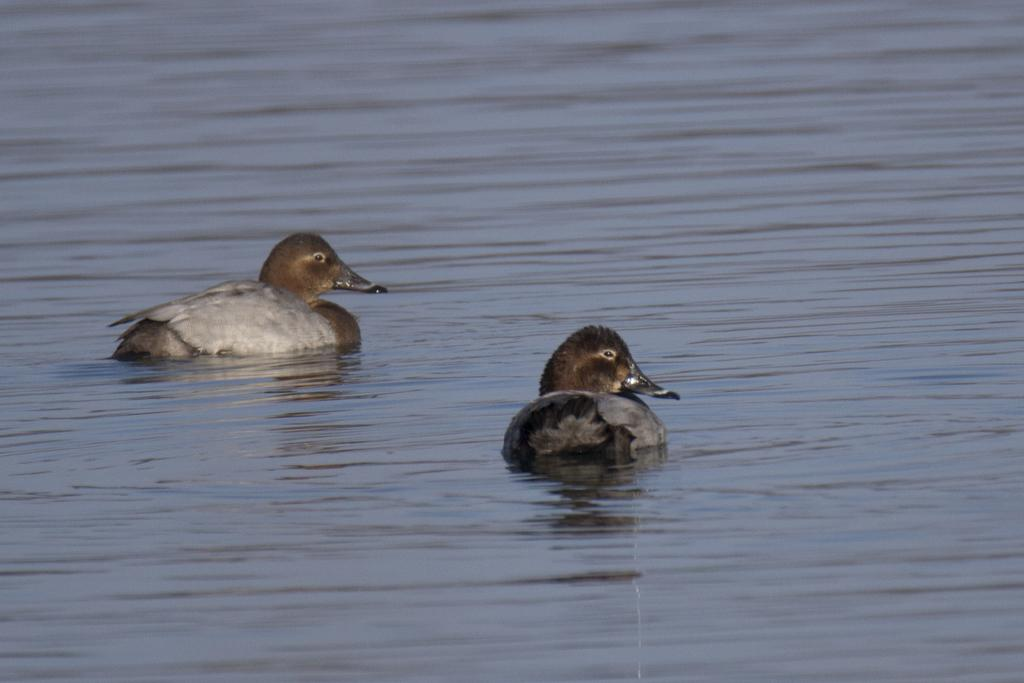How many birds are in the image? There are two birds in the image. Where are the birds located in the image? The birds are on the water. What type of meat can be seen hanging from the trees in the image? There are no trees or meat present in the image; it features two birds on the water. 